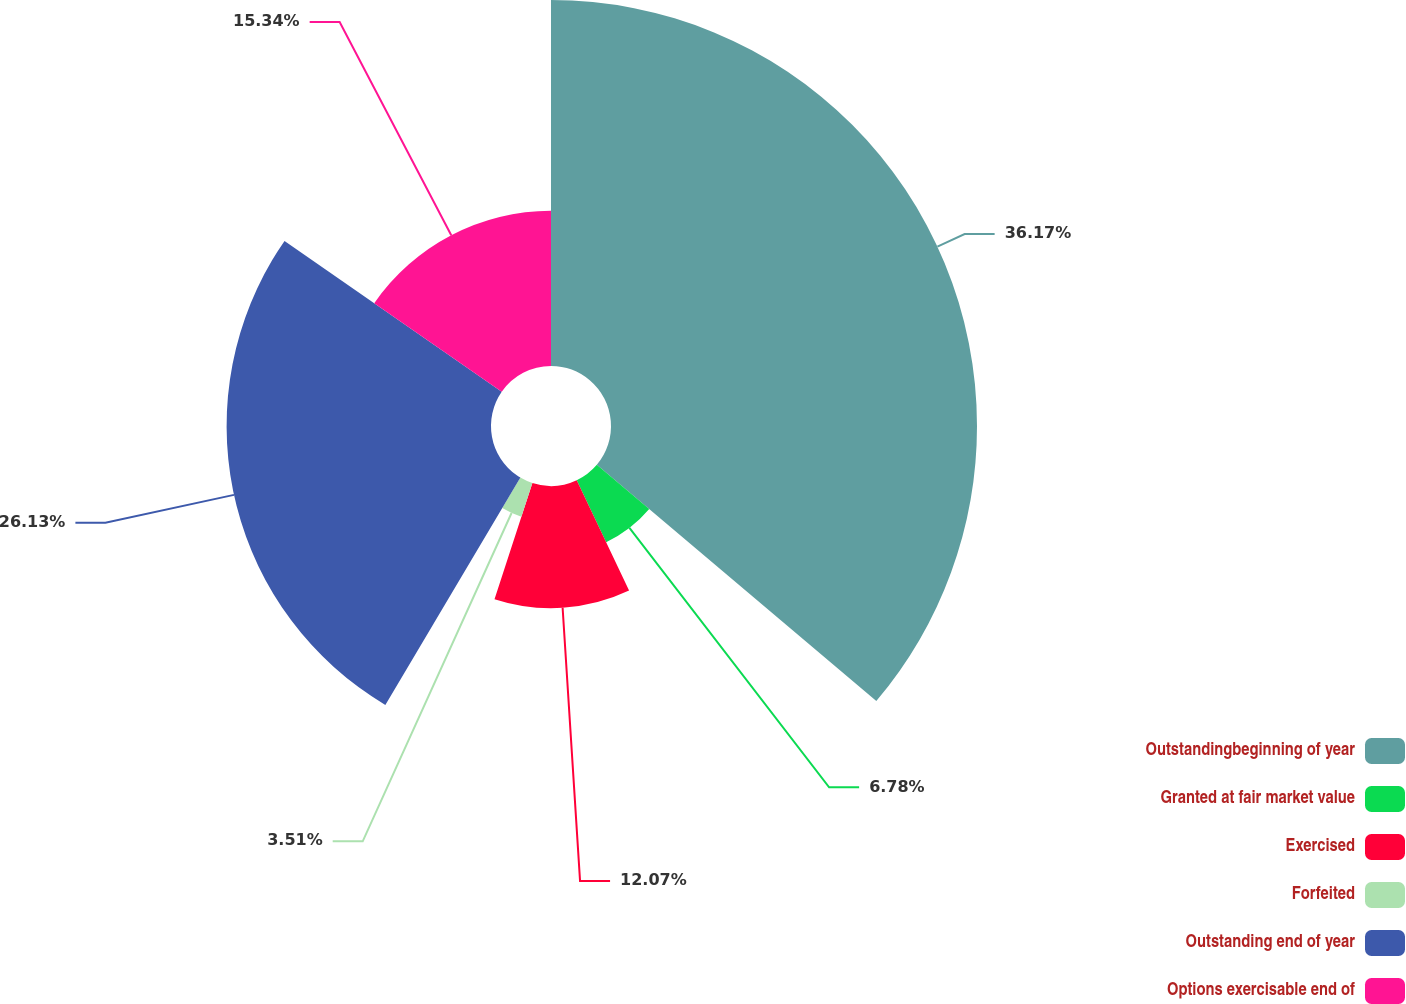Convert chart to OTSL. <chart><loc_0><loc_0><loc_500><loc_500><pie_chart><fcel>Outstandingbeginning of year<fcel>Granted at fair market value<fcel>Exercised<fcel>Forfeited<fcel>Outstanding end of year<fcel>Options exercisable end of<nl><fcel>36.17%<fcel>6.78%<fcel>12.07%<fcel>3.51%<fcel>26.13%<fcel>15.34%<nl></chart> 